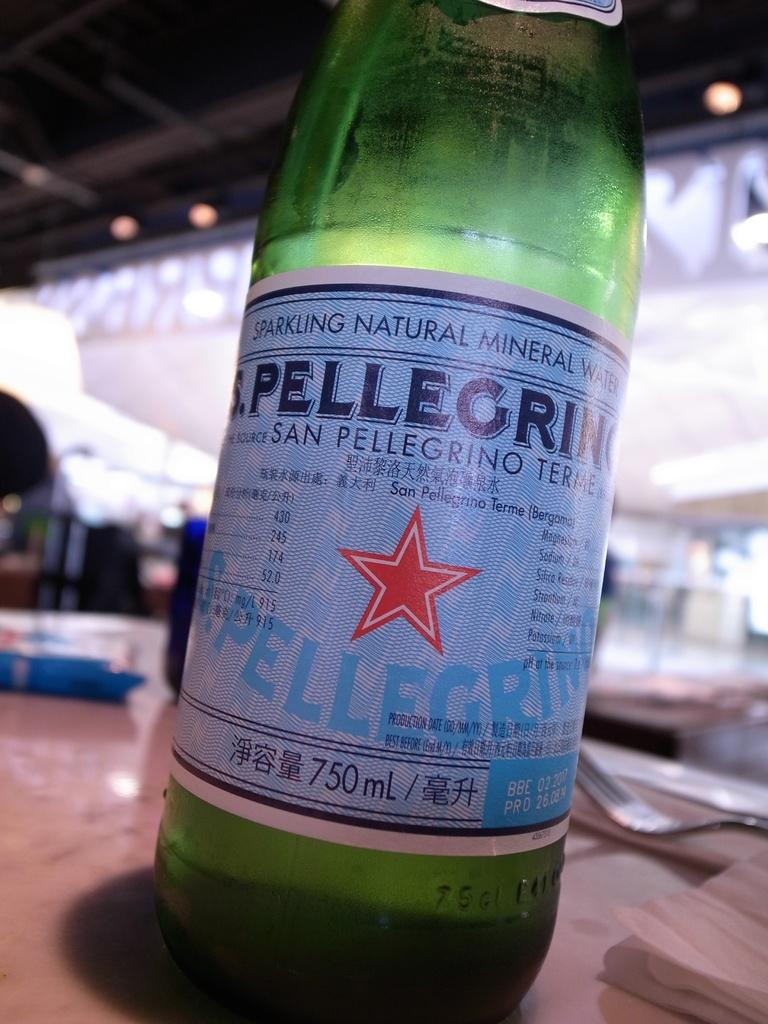<image>
Share a concise interpretation of the image provided. the number 750 that is on a bottle 